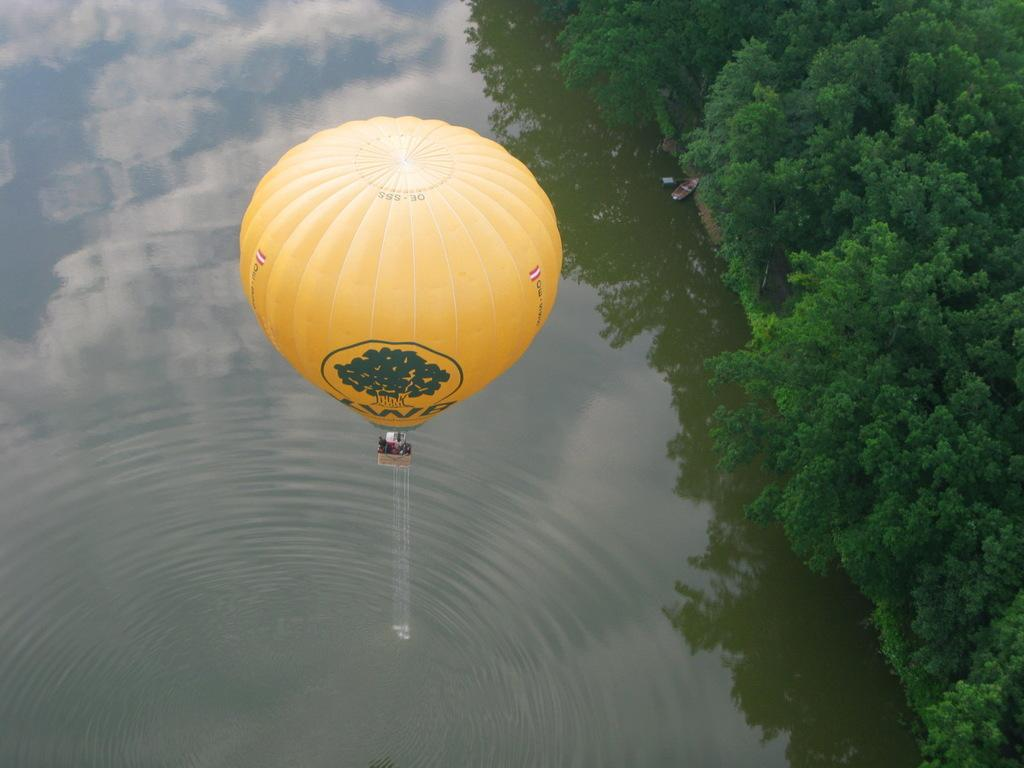What is the main subject in the center of the image? There is a balloon in the center of the image. What color is the balloon? The balloon is yellow in color. What can be seen on the right side of the image? There are trees on the right side of the image. What is present on the left side of the image? There is water on the left side of the image. How many socks can be seen hanging on the balloon in the image? There are no socks present in the image; it features a yellow balloon with trees on the right side and water on the left side. 